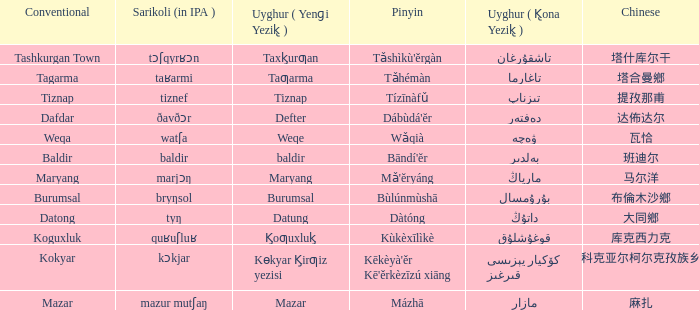Name the pinyin for mazar Mázhā. Would you mind parsing the complete table? {'header': ['Conventional', 'Sarikoli (in IPA )', 'Uyghur ( Yenɡi Yezik̢ )', 'Pinyin', 'Uyghur ( K̢ona Yezik̢ )', 'Chinese'], 'rows': [['Tashkurgan Town', 'tɔʃqyrʁɔn', 'Taxk̡urƣan', "Tǎshìkù'ěrgàn", 'تاشقۇرغان', '塔什库尔干'], ['Tagarma', 'taʁarmi', 'Taƣarma', 'Tǎhémàn', 'تاغارما', '塔合曼鄉'], ['Tiznap', 'tiznef', 'Tiznap', 'Tízīnàfǔ', 'تىزناپ', '提孜那甫'], ['Dafdar', 'ðavðɔr', 'Defter', "Dábùdá'ĕr", 'دەفتەر', '达佈达尔'], ['Weqa', 'watʃa', 'Weqe', 'Wǎqià', 'ۋەچە', '瓦恰'], ['Baldir', 'baldir', 'baldir', "Bāndí'ĕr", 'بەلدىر', '班迪尔'], ['Maryang', 'marjɔŋ', 'Maryang', "Mǎ'ĕryáng", 'مارياڭ', '马尔洋'], ['Burumsal', 'bryŋsol', 'Burumsal', 'Bùlúnmùshā', 'بۇرۇمسال', '布倫木沙鄉'], ['Datong', 'tyŋ', 'Datung', 'Dàtóng', 'داتۇڭ', '大同鄉'], ['Koguxluk', 'quʁuʃluʁ', 'K̡oƣuxluk̡', 'Kùkèxīlìkè', 'قوغۇشلۇق', '库克西力克'], ['Kokyar', 'kɔkjar', 'Kɵkyar K̡irƣiz yezisi', "Kēkèyà'ěr Kē'ěrkèzīzú xiāng", 'كۆكيار قىرغىز يېزىسى', '科克亚尔柯尔克孜族乡'], ['Mazar', 'mazur mutʃaŋ', 'Mazar', 'Mázhā', 'مازار', '麻扎']]} 